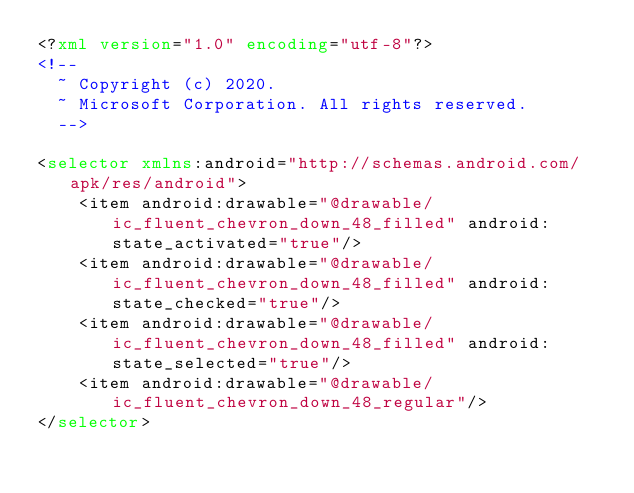Convert code to text. <code><loc_0><loc_0><loc_500><loc_500><_XML_><?xml version="1.0" encoding="utf-8"?>
<!--
  ~ Copyright (c) 2020.
  ~ Microsoft Corporation. All rights reserved.
  -->

<selector xmlns:android="http://schemas.android.com/apk/res/android">
    <item android:drawable="@drawable/ic_fluent_chevron_down_48_filled" android:state_activated="true"/>
    <item android:drawable="@drawable/ic_fluent_chevron_down_48_filled" android:state_checked="true"/>
    <item android:drawable="@drawable/ic_fluent_chevron_down_48_filled" android:state_selected="true"/>
    <item android:drawable="@drawable/ic_fluent_chevron_down_48_regular"/>
</selector>
</code> 